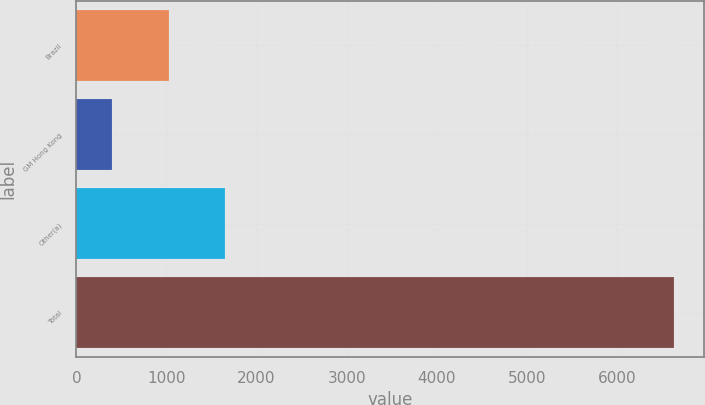Convert chart to OTSL. <chart><loc_0><loc_0><loc_500><loc_500><bar_chart><fcel>Brazil<fcel>GM Hong Kong<fcel>Other(a)<fcel>Total<nl><fcel>1023.2<fcel>400<fcel>1646.4<fcel>6632<nl></chart> 